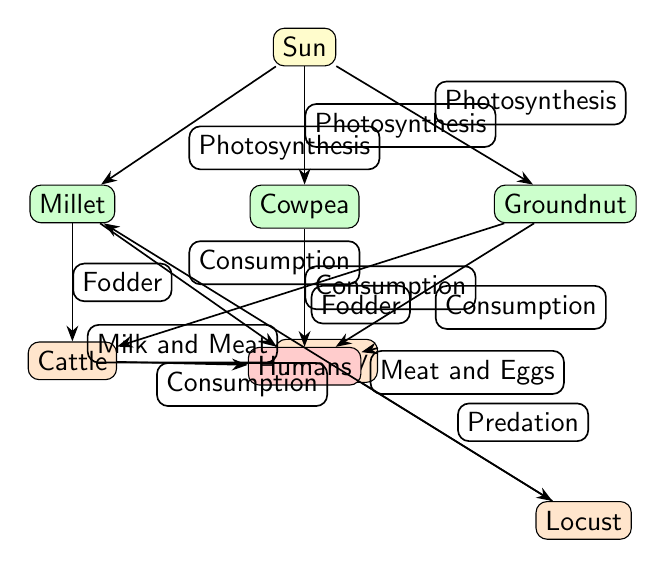What is the apex consumer in the food chain? The apex consumer is the highest level in the food chain, which in this diagram is "Humans."
Answer: Humans How many producers are in the diagram? The diagram contains three producers: "Millet," "Cowpea," and "Groundnut," which are directly connected to the "Sun."
Answer: 3 What do cattle consume in the food chain? Cattle consume "Millet" and "Groundnut" as fodder in the food chain.
Answer: Millet and Groundnut What products do poultry provide to humans? Poultry provides two key products to humans: "Meat and Eggs."
Answer: Meat and Eggs Which organism is a consumer of millet? The organisms that consume millet, as per the diagram, are "Cattle" and "Locust."
Answer: Cattle and Locust How many edges are connected to the "Sun"? The "Sun" has three edges connecting it to the producers: "Millet," "Cowpea," and "Groundnut."
Answer: 3 What is the relationship between locust and poultry? The relationship is based on "Predation," where poultry preys on locust.
Answer: Predation How do humans obtain milk and meat in the food chain? Humans obtain milk and meat through the consumption of "Cattle," which is represented by the edge labeled "Milk and Meat."
Answer: Cattle What is the primary energy source for all the producers in the diagram? The primary energy source for all producers is the "Sun," as it is the starting point of energy flow for photosynthesis.
Answer: Sun 